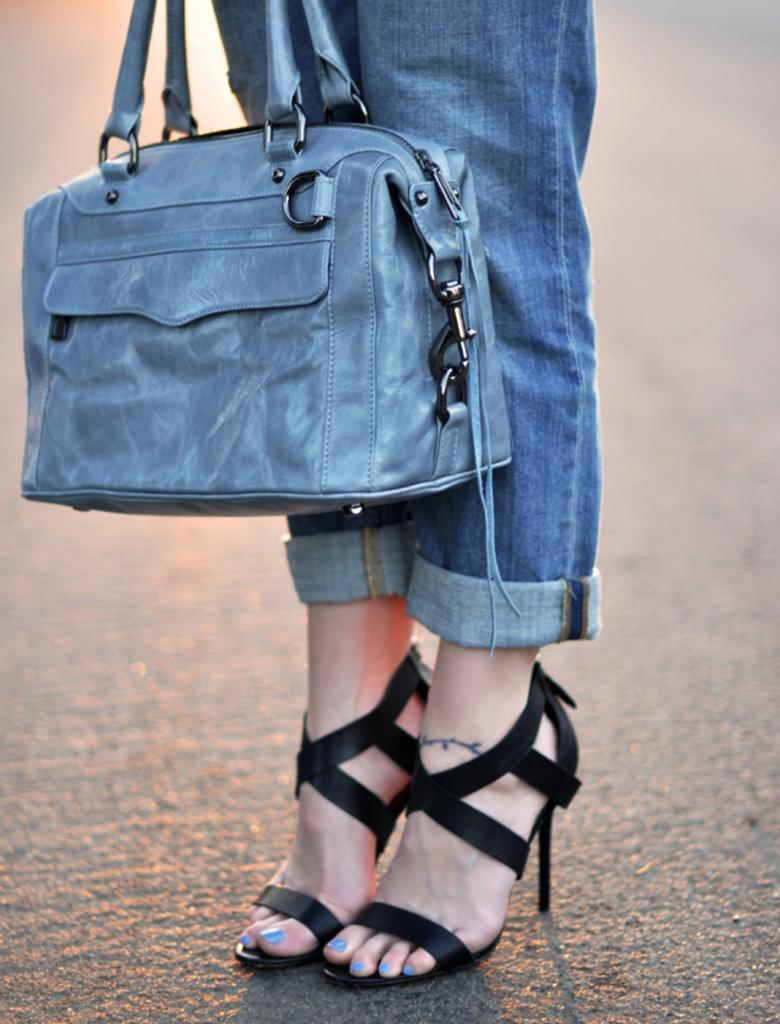What can be seen in the image? There is a person in the image. What is the person holding? The person is holding a bag. What type of footwear is the person wearing? The person is wearing sandals. What statement does the person make in the image? There is no statement made by the person in the image; we can only observe their actions and appearance. 